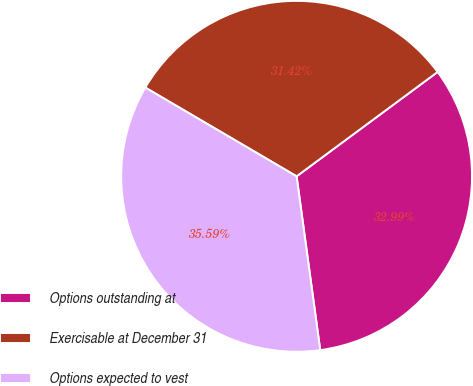Convert chart. <chart><loc_0><loc_0><loc_500><loc_500><pie_chart><fcel>Options outstanding at<fcel>Exercisable at December 31<fcel>Options expected to vest<nl><fcel>32.99%<fcel>31.42%<fcel>35.59%<nl></chart> 